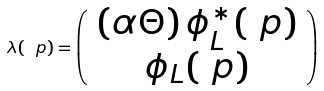<formula> <loc_0><loc_0><loc_500><loc_500>\lambda ( \ p ) = \left ( \begin{array} { c } \left ( \alpha \Theta \right ) \phi _ { L } ^ { \ast } ( \ p ) \\ \phi _ { L } ( \ p ) \end{array} \right )</formula> 